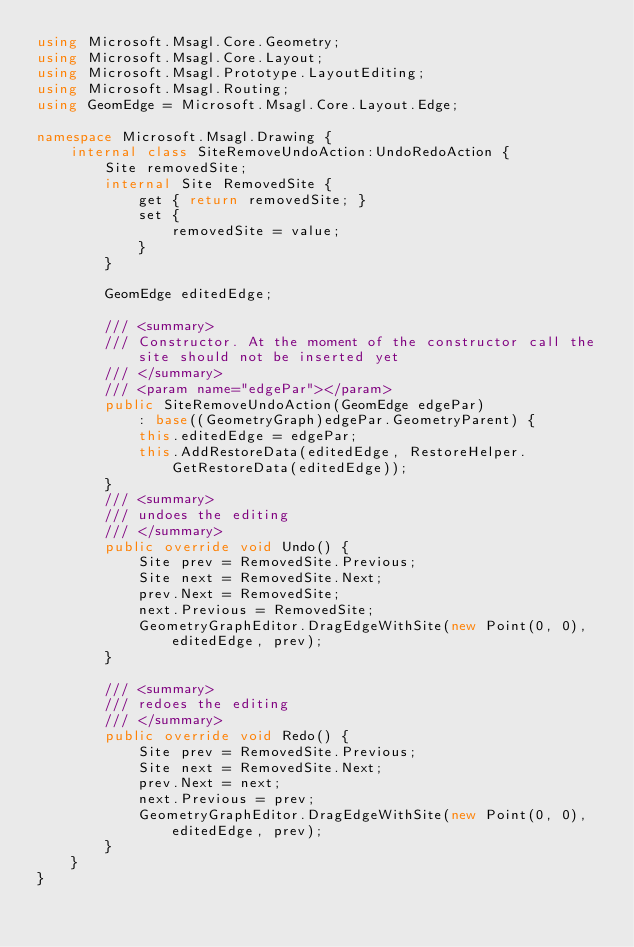<code> <loc_0><loc_0><loc_500><loc_500><_C#_>using Microsoft.Msagl.Core.Geometry;
using Microsoft.Msagl.Core.Layout;
using Microsoft.Msagl.Prototype.LayoutEditing;
using Microsoft.Msagl.Routing;
using GeomEdge = Microsoft.Msagl.Core.Layout.Edge;

namespace Microsoft.Msagl.Drawing {
    internal class SiteRemoveUndoAction:UndoRedoAction {
        Site removedSite;
        internal Site RemovedSite {
            get { return removedSite; }
            set { 
                removedSite = value;
            }
        }

        GeomEdge editedEdge;

        /// <summary>
        /// Constructor. At the moment of the constructor call the site should not be inserted yet
        /// </summary>
        /// <param name="edgePar"></param>
        public SiteRemoveUndoAction(GeomEdge edgePar)
            : base((GeometryGraph)edgePar.GeometryParent) {
            this.editedEdge = edgePar;
            this.AddRestoreData(editedEdge, RestoreHelper.GetRestoreData(editedEdge));
        }
        /// <summary>
        /// undoes the editing
        /// </summary>
        public override void Undo() {
            Site prev = RemovedSite.Previous;
            Site next = RemovedSite.Next;
            prev.Next = RemovedSite;
            next.Previous = RemovedSite;
            GeometryGraphEditor.DragEdgeWithSite(new Point(0, 0), editedEdge, prev);
        }

        /// <summary>
        /// redoes the editing
        /// </summary>
        public override void Redo() {
            Site prev = RemovedSite.Previous;
            Site next = RemovedSite.Next;
            prev.Next = next;
            next.Previous = prev;
            GeometryGraphEditor.DragEdgeWithSite(new Point(0, 0), editedEdge, prev);
        }
    }
}
</code> 